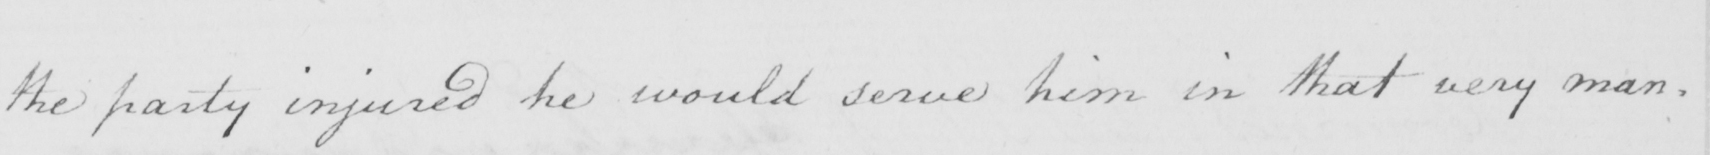Please transcribe the handwritten text in this image. the party injured he would serve him in that very man- 